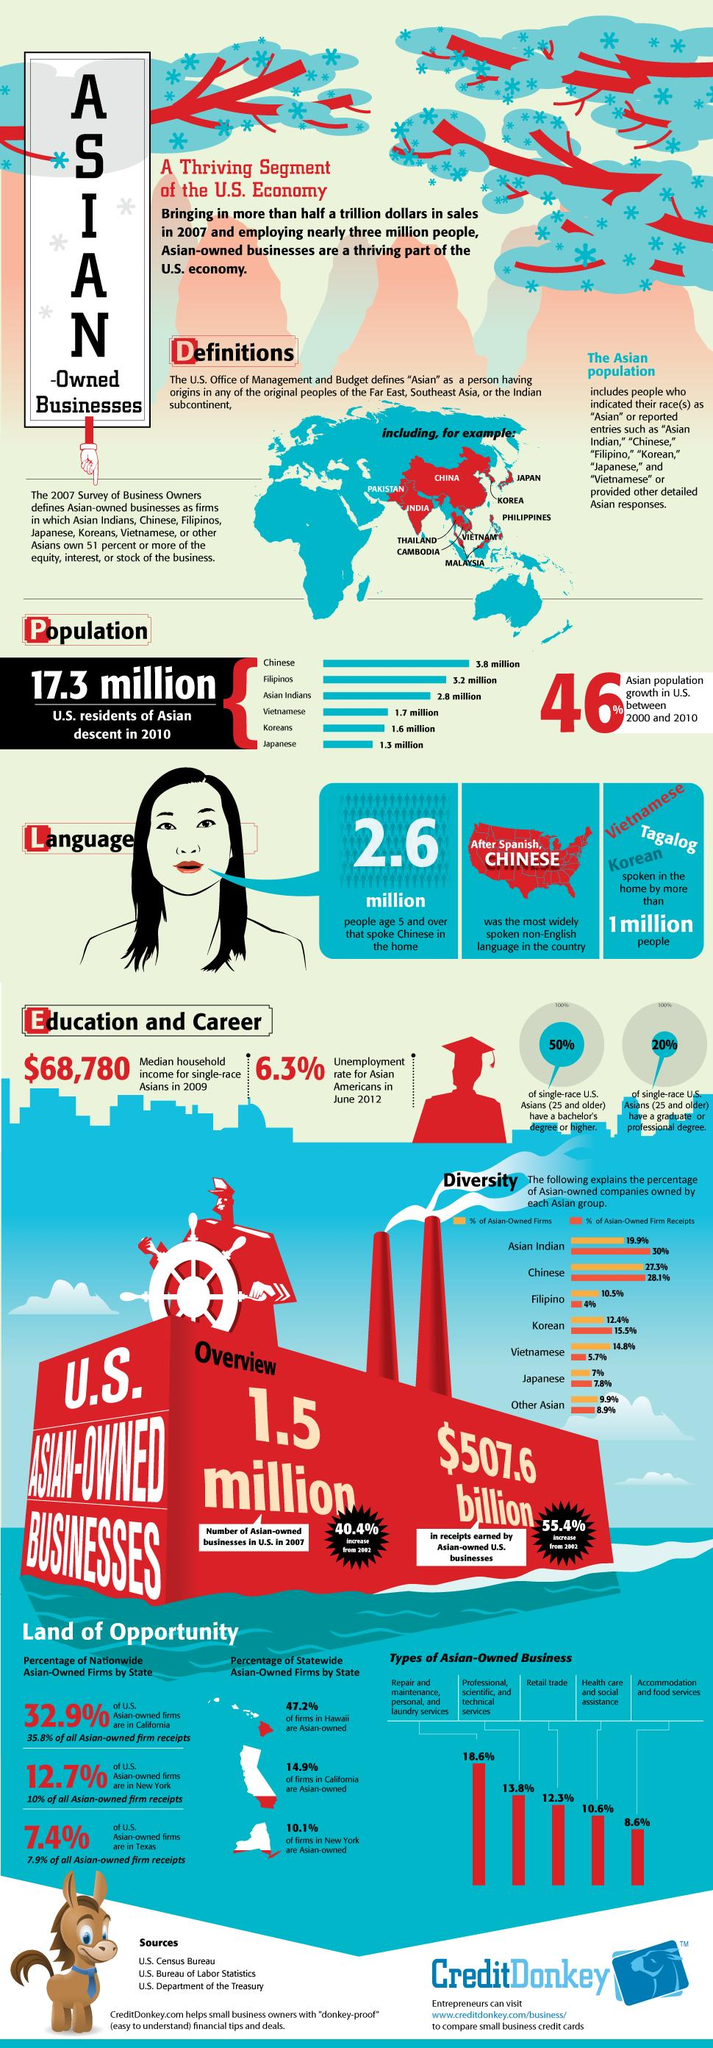Indicate a few pertinent items in this graphic. Asian Indians make up the third largest Asian population in the United States. Filipinos are the people of a country that has the second-largest population in the United States. In California, a significant percentage of firms are not owned by Asians, with 85.1% falling into this category. According to recent statistics, only 10.1% of firms in New York are owned by Asian individuals or entities. According to data, 32.9% of U.S. Asian-owned firms are located in the state of California. 